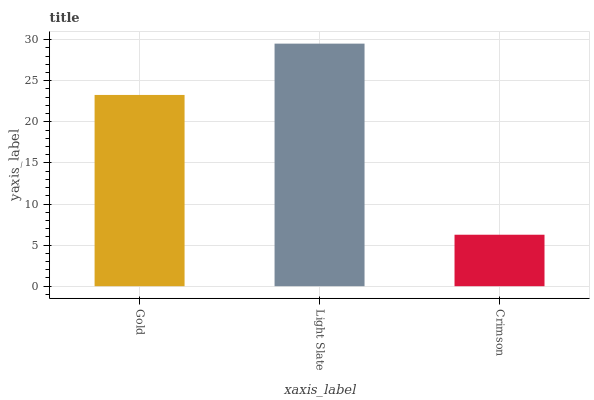Is Crimson the minimum?
Answer yes or no. Yes. Is Light Slate the maximum?
Answer yes or no. Yes. Is Light Slate the minimum?
Answer yes or no. No. Is Crimson the maximum?
Answer yes or no. No. Is Light Slate greater than Crimson?
Answer yes or no. Yes. Is Crimson less than Light Slate?
Answer yes or no. Yes. Is Crimson greater than Light Slate?
Answer yes or no. No. Is Light Slate less than Crimson?
Answer yes or no. No. Is Gold the high median?
Answer yes or no. Yes. Is Gold the low median?
Answer yes or no. Yes. Is Light Slate the high median?
Answer yes or no. No. Is Light Slate the low median?
Answer yes or no. No. 